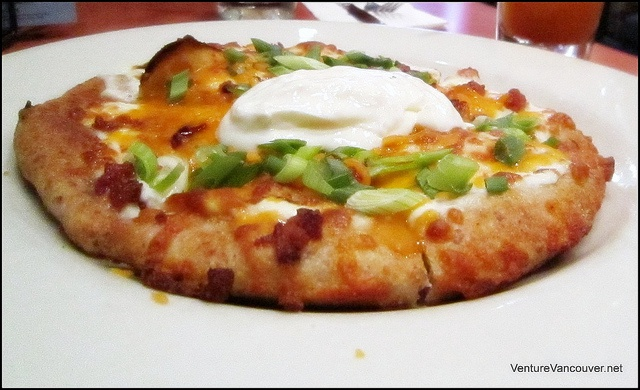Describe the objects in this image and their specific colors. I can see pizza in black, brown, white, tan, and maroon tones, dining table in black, maroon, and brown tones, cup in black, maroon, and brown tones, cup in black, darkgray, and gray tones, and fork in black, darkgray, and lightgray tones in this image. 